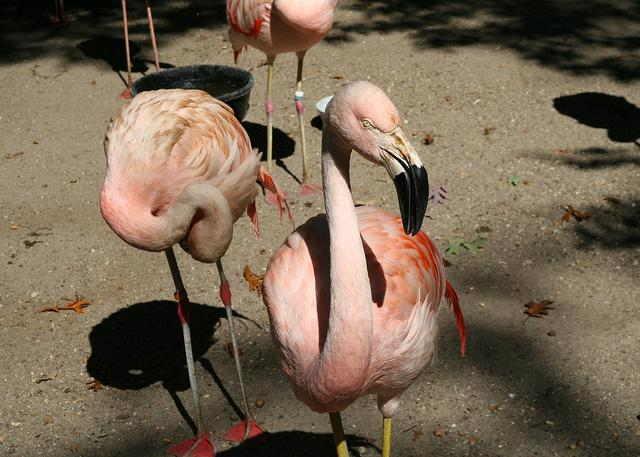What aquatic order are these birds from? Please explain your reasoning. phoenicopteriformes. Flamingoes come from phoenicopteriformes. 